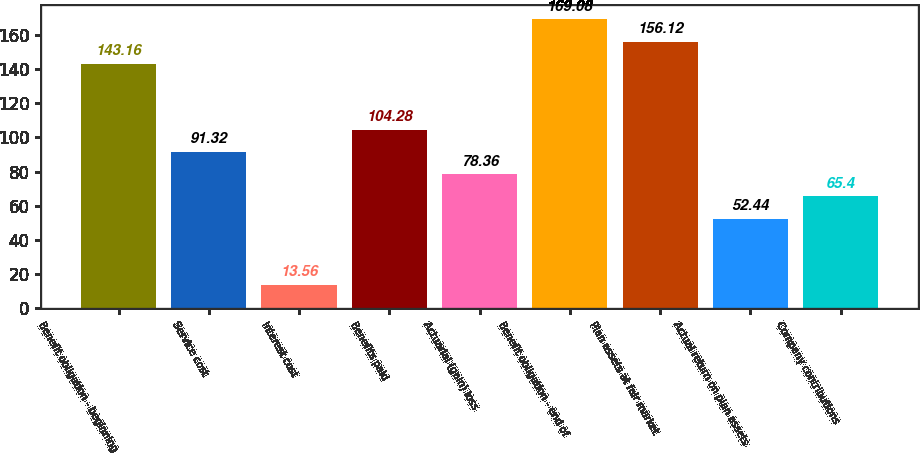<chart> <loc_0><loc_0><loc_500><loc_500><bar_chart><fcel>Benefit obligation - beginning<fcel>Service cost<fcel>Interest cost<fcel>Benefits paid<fcel>Actuarial (gain) loss<fcel>Benefit obligation - end of<fcel>Plan assets at fair market<fcel>Actual return on plan assets<fcel>Company contributions<nl><fcel>143.16<fcel>91.32<fcel>13.56<fcel>104.28<fcel>78.36<fcel>169.08<fcel>156.12<fcel>52.44<fcel>65.4<nl></chart> 